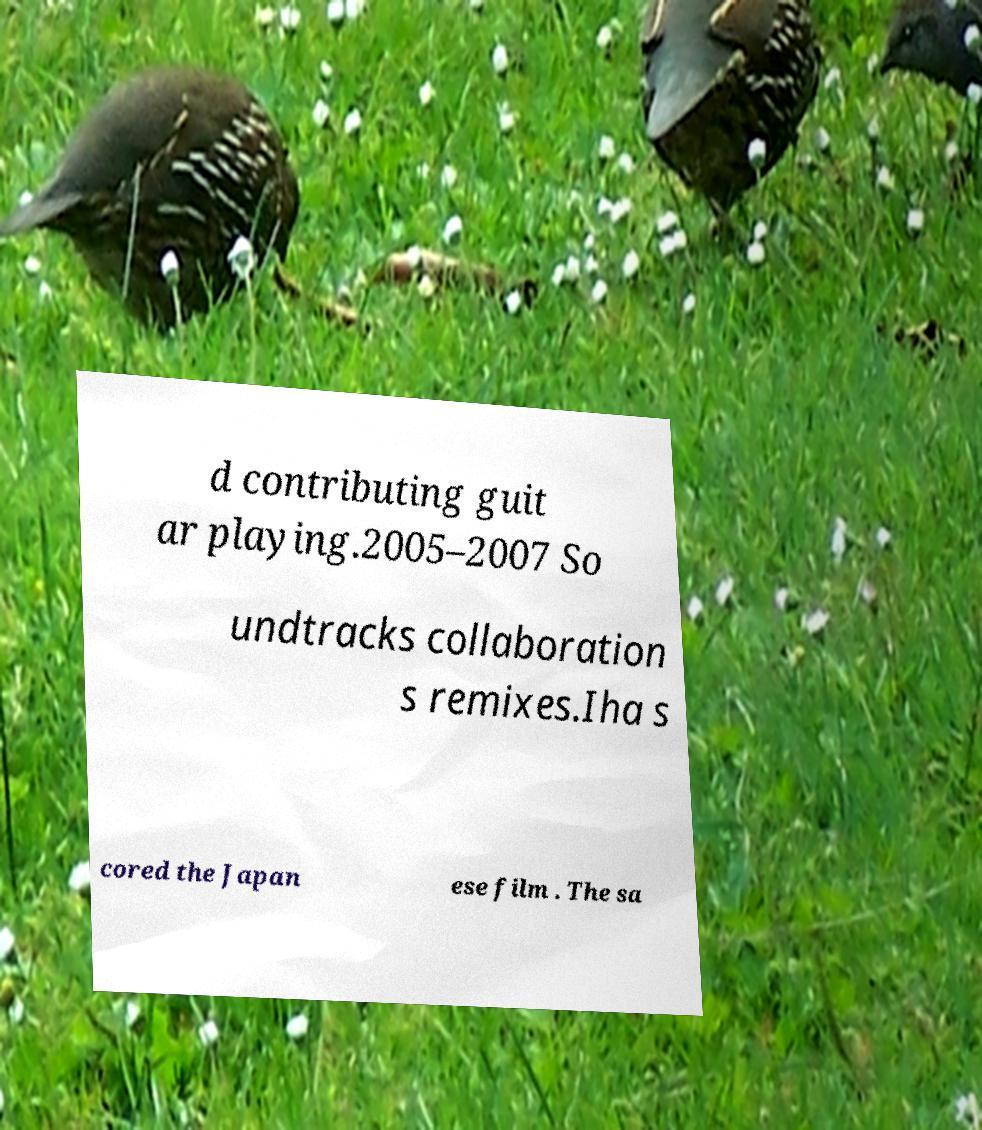There's text embedded in this image that I need extracted. Can you transcribe it verbatim? d contributing guit ar playing.2005–2007 So undtracks collaboration s remixes.Iha s cored the Japan ese film . The sa 